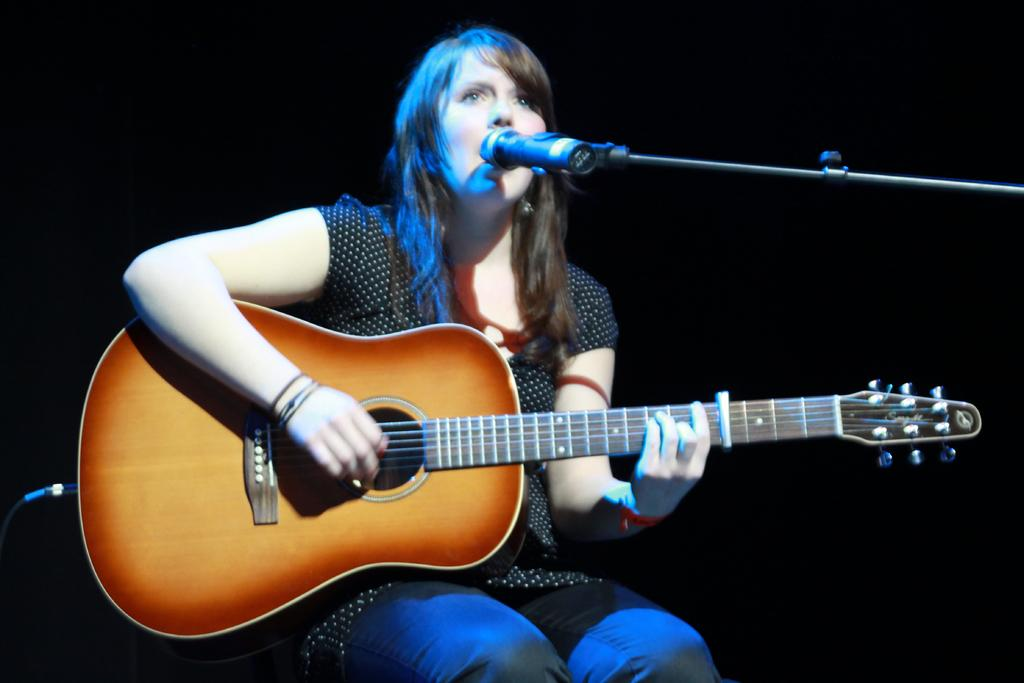What is the person in the image doing? The person is sitting, playing a guitar, and singing. What is the person wearing in the image? The person is wearing a black dress. What object is present in the image that is typically used for amplifying sound? There is a microphone with a stand in the image. What type of zinc is present on the stage in the image? There is no stage or zinc present in the image. Can you tell me the name of the man playing the guitar in the image? The provided facts do not include the person's name, only their activity and clothing. 